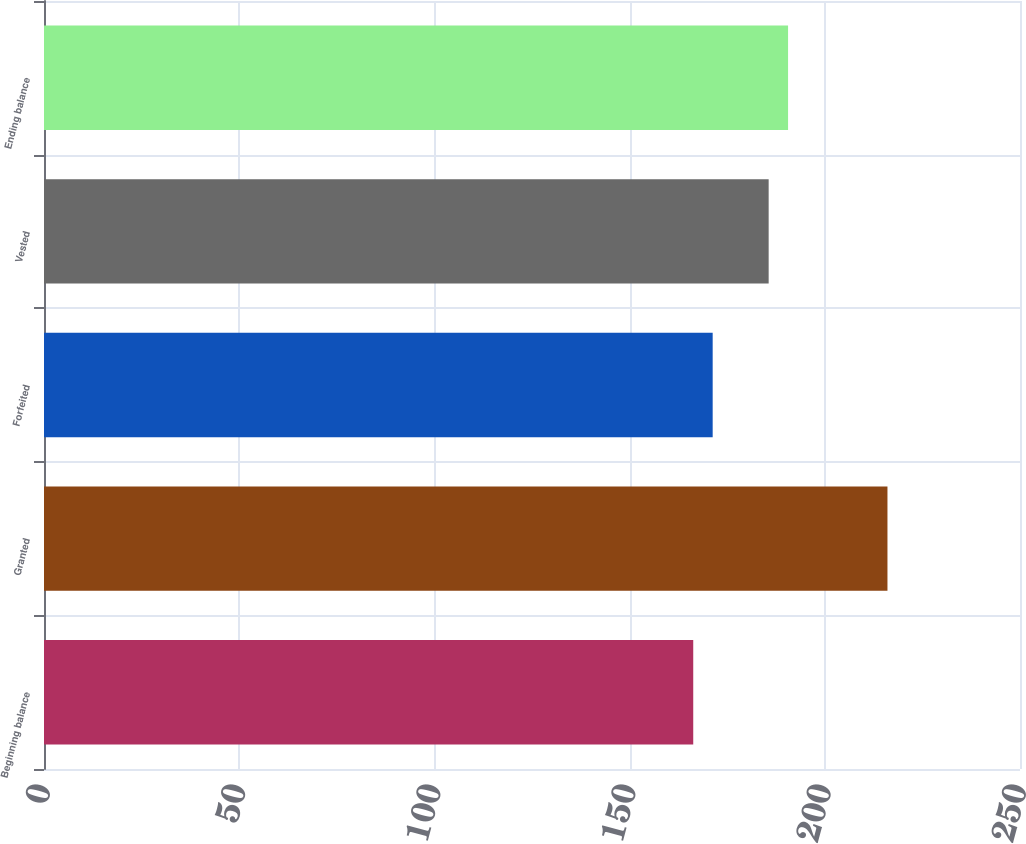Convert chart. <chart><loc_0><loc_0><loc_500><loc_500><bar_chart><fcel>Beginning balance<fcel>Granted<fcel>Forfeited<fcel>Vested<fcel>Ending balance<nl><fcel>166.3<fcel>216.05<fcel>171.28<fcel>185.62<fcel>190.59<nl></chart> 